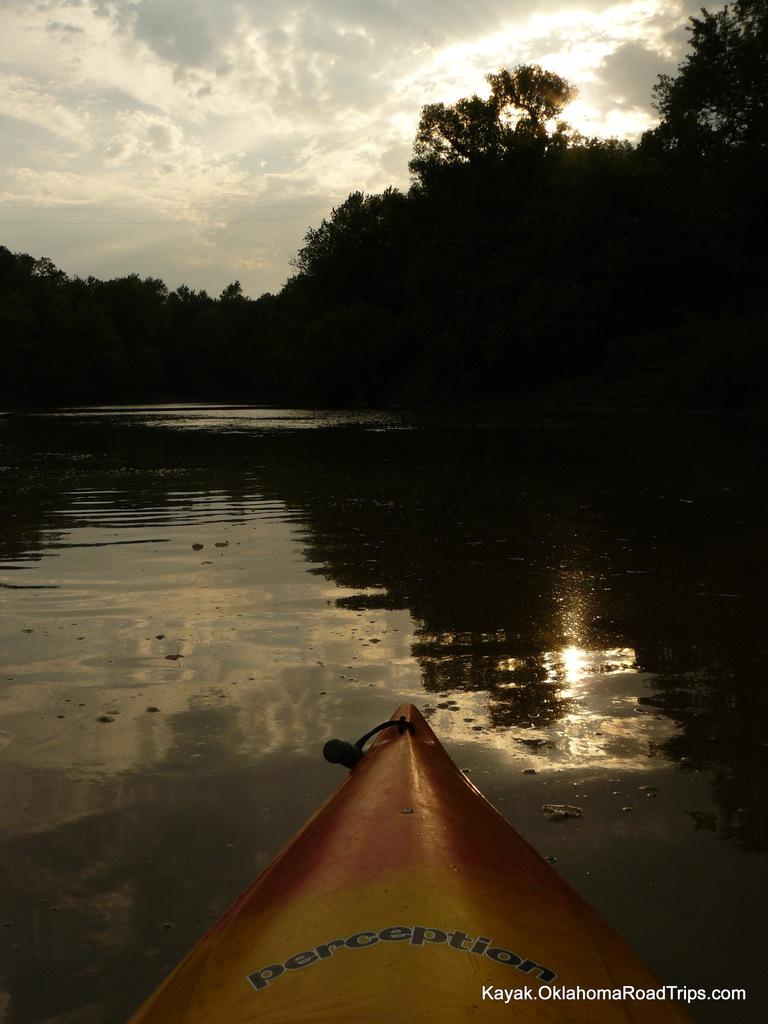What type of scene is depicted in the image? The image contains a beautiful view of nature. What body of water can be seen in the image? There is a river in the image. What surrounds the river in the image? Trees are present around the river. What is visible in the sky in the image? The sky is visible in the image. What is the condition of the sky in the image? The sky is clear and blue. What type of vegetable is floating in the river in the image? There are no vegetables present in the image, and nothing is floating in the river. What is the cork used for in the image? There is no cork present in the image. 